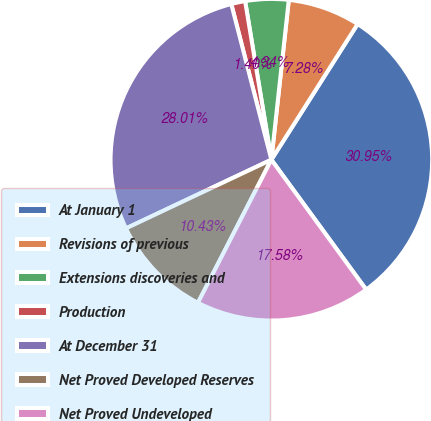Convert chart. <chart><loc_0><loc_0><loc_500><loc_500><pie_chart><fcel>At January 1<fcel>Revisions of previous<fcel>Extensions discoveries and<fcel>Production<fcel>At December 31<fcel>Net Proved Developed Reserves<fcel>Net Proved Undeveloped<nl><fcel>30.95%<fcel>7.28%<fcel>4.34%<fcel>1.4%<fcel>28.01%<fcel>10.43%<fcel>17.58%<nl></chart> 